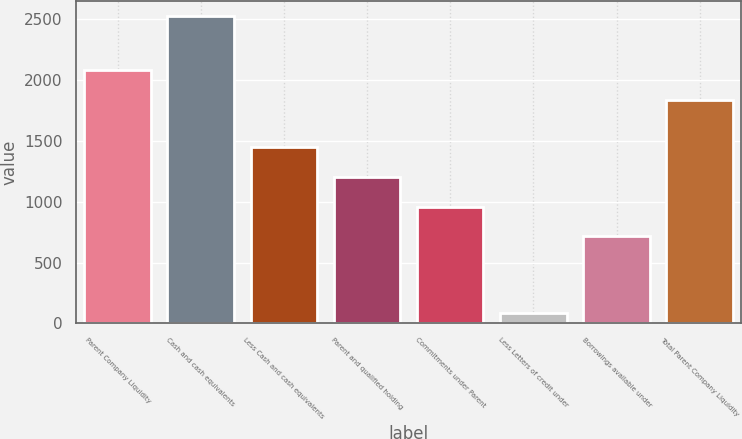Convert chart. <chart><loc_0><loc_0><loc_500><loc_500><bar_chart><fcel>Parent Company Liquidity<fcel>Cash and cash equivalents<fcel>Less Cash and cash equivalents<fcel>Parent and qualified holding<fcel>Commitments under Parent<fcel>Less Letters of credit under<fcel>Borrowings available under<fcel>Total Parent Company Liquidity<nl><fcel>2081<fcel>2525<fcel>1447<fcel>1203<fcel>959<fcel>85<fcel>715<fcel>1837<nl></chart> 